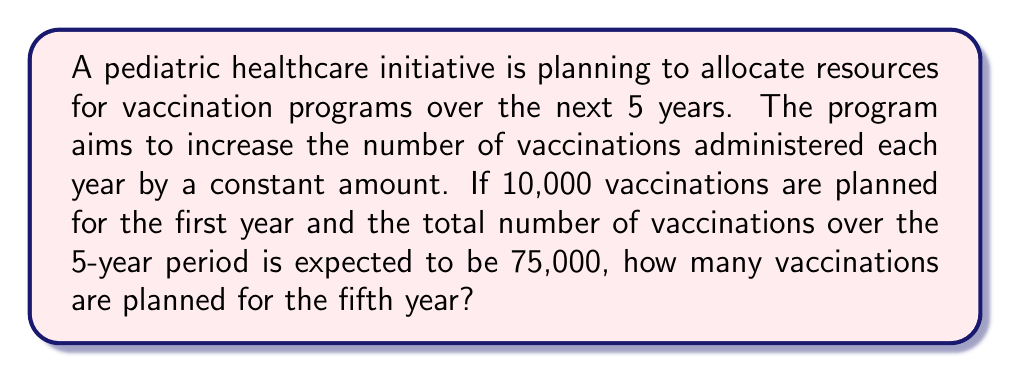What is the answer to this math problem? Let's approach this step-by-step using arithmetic sequence principles:

1) Let $a$ be the first term (10,000 vaccinations in the first year) and $d$ be the common difference (yearly increase).

2) The arithmetic sequence for the 5 years will be:
   $a, a+d, a+2d, a+3d, a+4d$

3) The sum of an arithmetic sequence is given by:
   $S_n = \frac{n}{2}(a_1 + a_n)$, where $n$ is the number of terms, $a_1$ is the first term, and $a_n$ is the last term.

4) We know that $S_5 = 75,000$, $n = 5$, and $a_1 = 10,000$. Let's call the last term $a_5 = x$.

5) Substituting into the formula:
   $75,000 = \frac{5}{2}(10,000 + x)$

6) Solving for $x$:
   $75,000 = 25,000 + \frac{5x}{2}$
   $50,000 = \frac{5x}{2}$
   $x = 20,000$

7) To verify, let's calculate $d$:
   $d = \frac{x - a}{4} = \frac{20,000 - 10,000}{4} = 2,500$

8) The sequence is thus: 10,000, 12,500, 15,000, 17,500, 20,000

Therefore, in the fifth year, 20,000 vaccinations are planned.
Answer: 20,000 vaccinations 